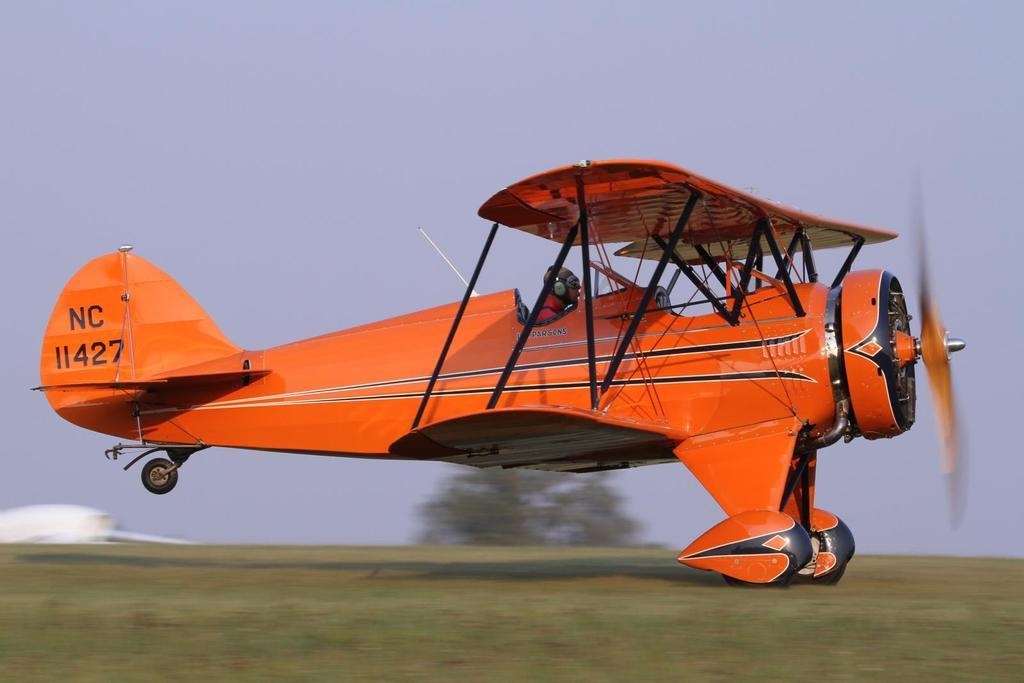<image>
Provide a brief description of the given image. An orange plane with a call sign of NC 11427 taking off. 